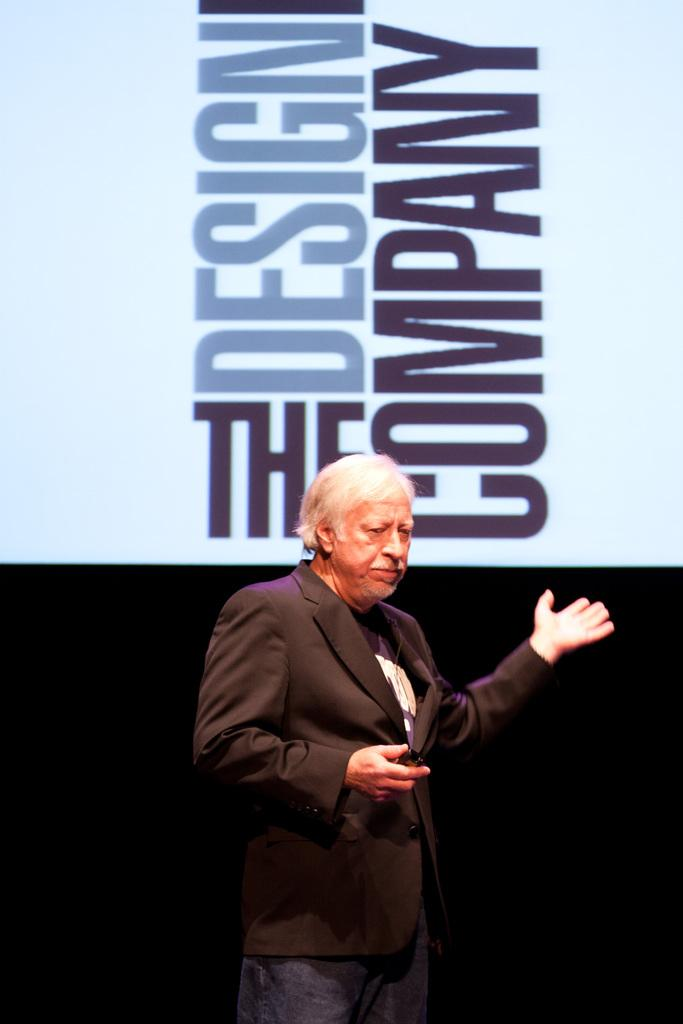<image>
Provide a brief description of the given image. A man standing in front of a sign saying the design company 